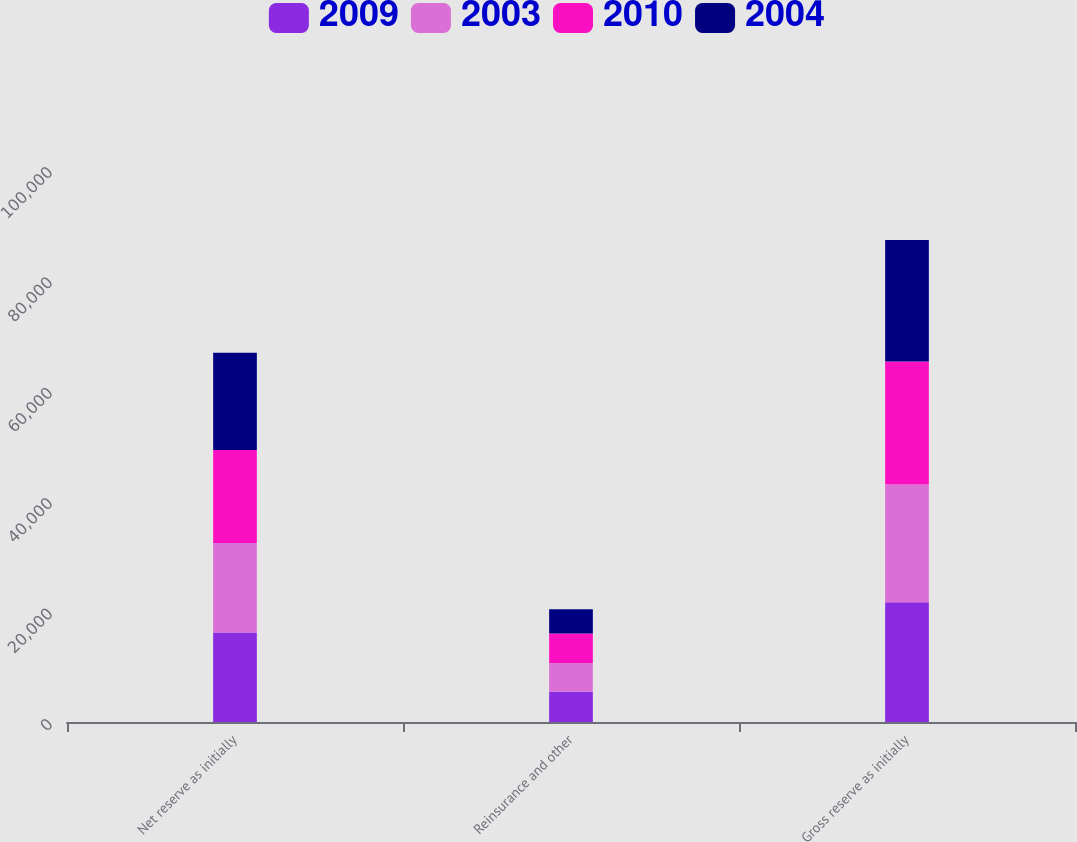Convert chart. <chart><loc_0><loc_0><loc_500><loc_500><stacked_bar_chart><ecel><fcel>Net reserve as initially<fcel>Reinsurance and other<fcel>Gross reserve as initially<nl><fcel>2009<fcel>16218<fcel>5497<fcel>21715<nl><fcel>2003<fcel>16191<fcel>5138<fcel>21329<nl><fcel>2010<fcel>16863<fcel>5403<fcel>22266<nl><fcel>2004<fcel>17604<fcel>4387<fcel>21991<nl></chart> 